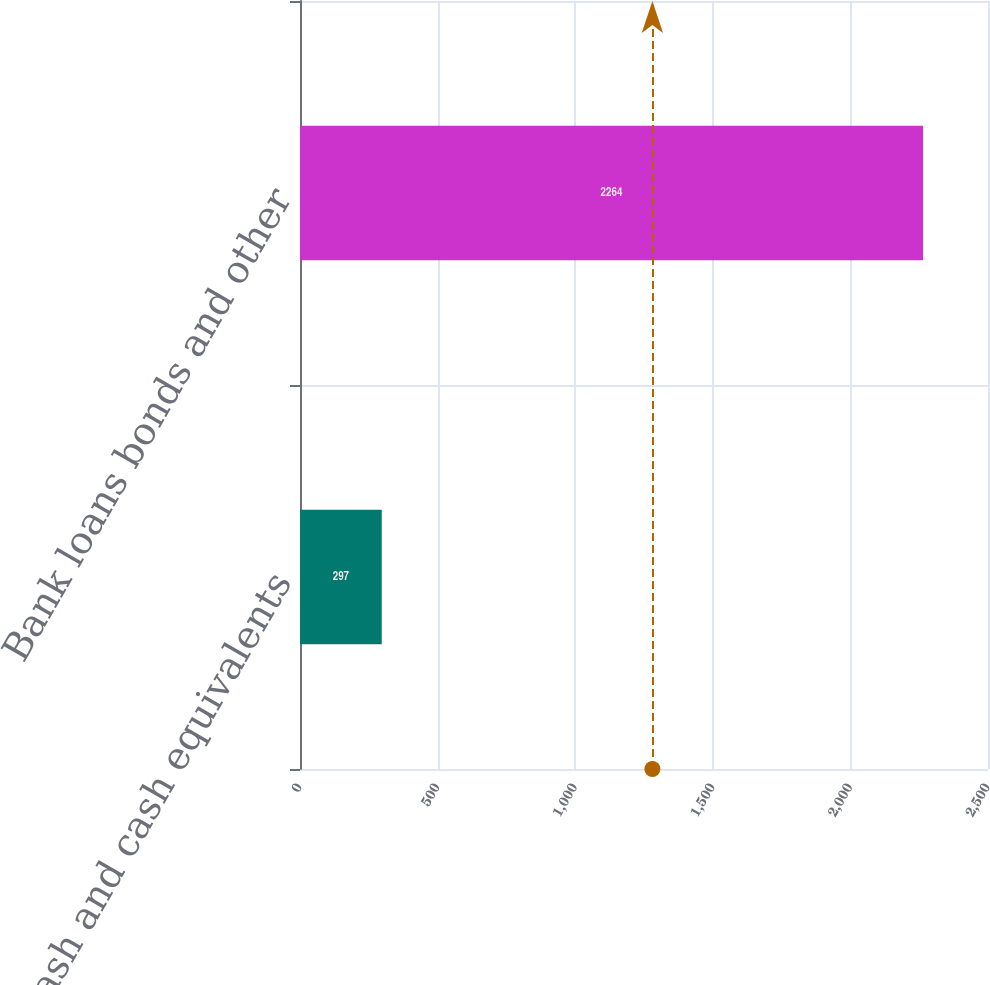Convert chart to OTSL. <chart><loc_0><loc_0><loc_500><loc_500><bar_chart><fcel>Cash and cash equivalents<fcel>Bank loans bonds and other<nl><fcel>297<fcel>2264<nl></chart> 